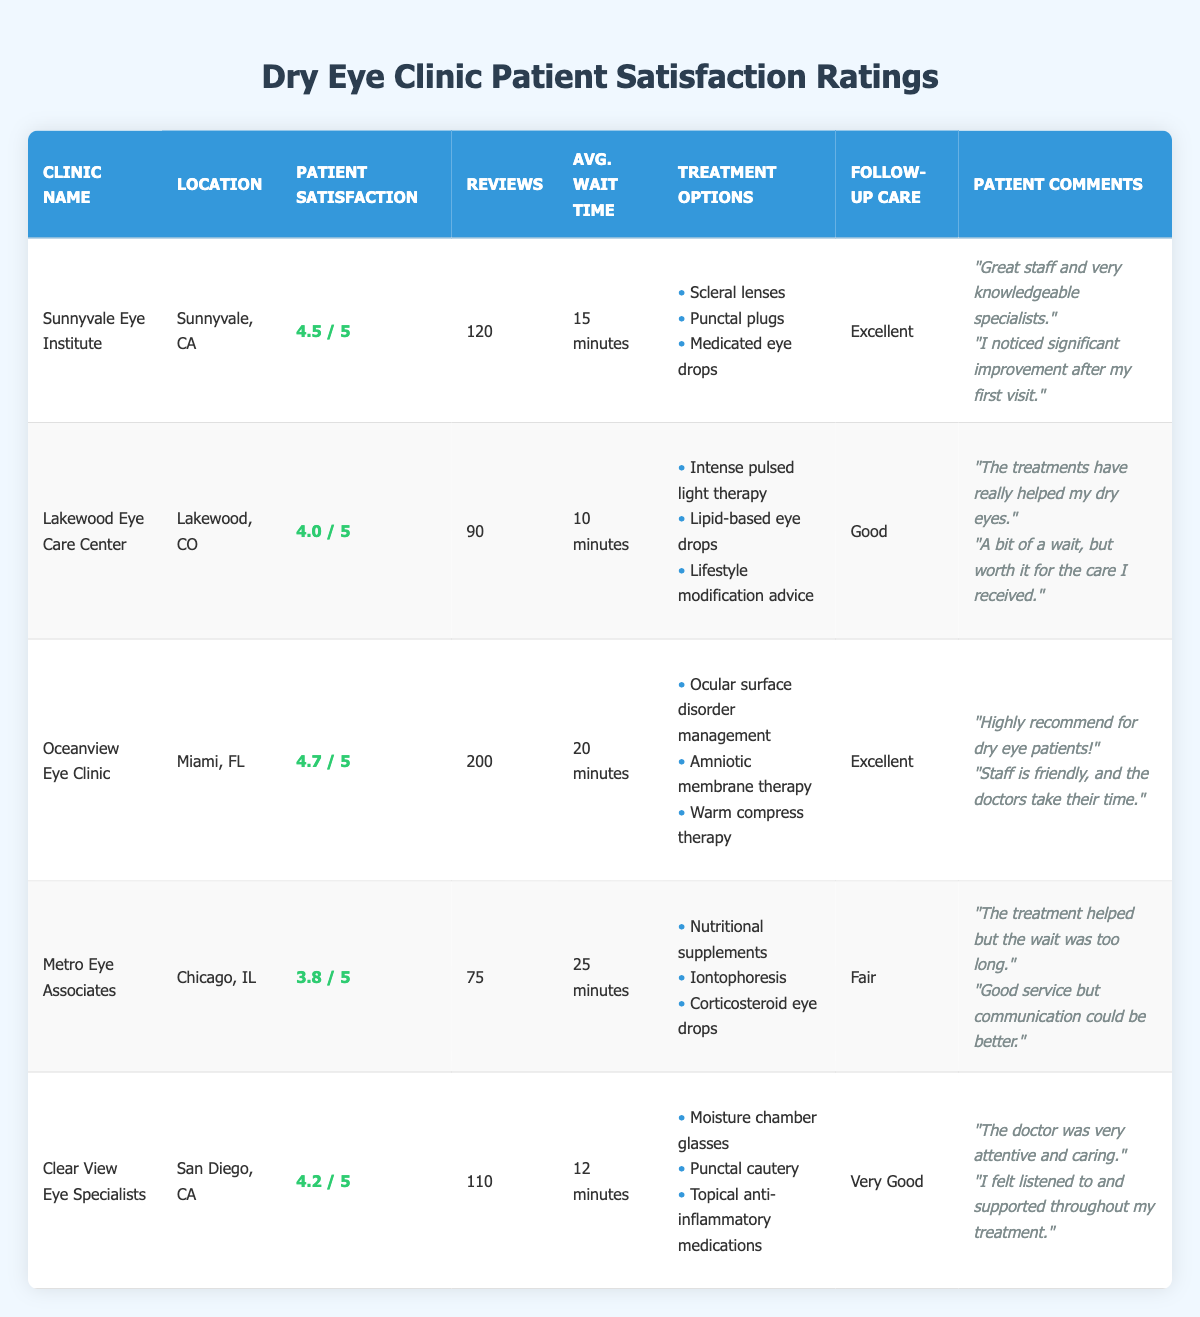What is the patient satisfaction rating for Oceanview Eye Clinic? The table shows the patient satisfaction rating for each clinic. For Oceanview Eye Clinic, the rating is listed directly in the table as 4.7.
Answer: 4.7 Which clinic has the highest patient satisfaction rating? By comparing the ratings listed in the table, Oceanview Eye Clinic has the highest rating at 4.7, followed by Sunnyvale Eye Institute at 4.5.
Answer: Oceanview Eye Clinic How many reviews did Metro Eye Associates receive? The table provides the number of reviews for each clinic. For Metro Eye Associates, it indicates there were 75 reviews.
Answer: 75 What is the average wait time for Lakewood Eye Care Center? The average wait time for Lakewood Eye Care Center is listed in the table as 10 minutes.
Answer: 10 minutes Which clinic offers the treatment option of Scleral lenses? By reviewing the treatment options in the table, Scleral lenses are listed as an option under Sunnyvale Eye Institute.
Answer: Sunnyvale Eye Institute How does the follow-up care at Clear View Eye Specialists compare to that at Metro Eye Associates? The follow-up care for Clear View Eye Specialists is rated as "Very Good," while for Metro Eye Associates, it is rated as "Fair." This indicates that Clear View Eye Specialists provides a generally better follow-up care experience compared to Metro Eye Associates.
Answer: Clear View Eye Specialists has better follow-up care What is the difference in patient satisfaction ratings between Oceanview Eye Clinic and Lakewood Eye Care Center? Oceanview Eye Clinic has a rating of 4.7, and Lakewood Eye Care Center has a rating of 4.0. To find the difference, subtract 4.0 from 4.7, which equals 0.7.
Answer: 0.7 Which clinic has the longest average wait time, and what is that time? By comparing the average wait times in the table, Metro Eye Associates shows the longest average wait time at 25 minutes.
Answer: Metro Eye Associates, 25 minutes Are there any clinics that provide Amniotic membrane therapy? The table indicates that only Oceanview Eye Clinic lists Amniotic membrane therapy as one of its treatment options.
Answer: Yes, Oceanview Eye Clinic Determine the total number of reviews for clinics with a patient satisfaction rating above 4.0. The clinics with ratings above 4.0 are Sunnyvale Eye Institute (120 reviews), Oceanview Eye Clinic (200 reviews), and Clear View Eye Specialists (110 reviews). Adding these together: 120 + 200 + 110 = 430 total reviews.
Answer: 430 Is the patient comment for Sunnyvale Eye Institute positive or negative? The patient comments for Sunnyvale Eye Institute reflect positive experiences, mentioning knowledgeable specialists and significant improvement after treatment.
Answer: Positive 